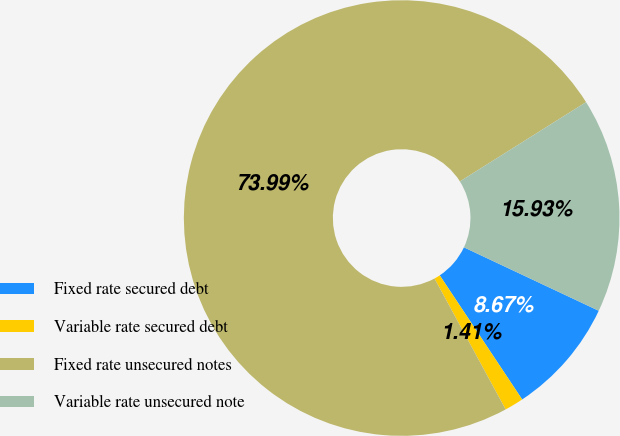Convert chart. <chart><loc_0><loc_0><loc_500><loc_500><pie_chart><fcel>Fixed rate secured debt<fcel>Variable rate secured debt<fcel>Fixed rate unsecured notes<fcel>Variable rate unsecured note<nl><fcel>8.67%<fcel>1.41%<fcel>73.99%<fcel>15.93%<nl></chart> 